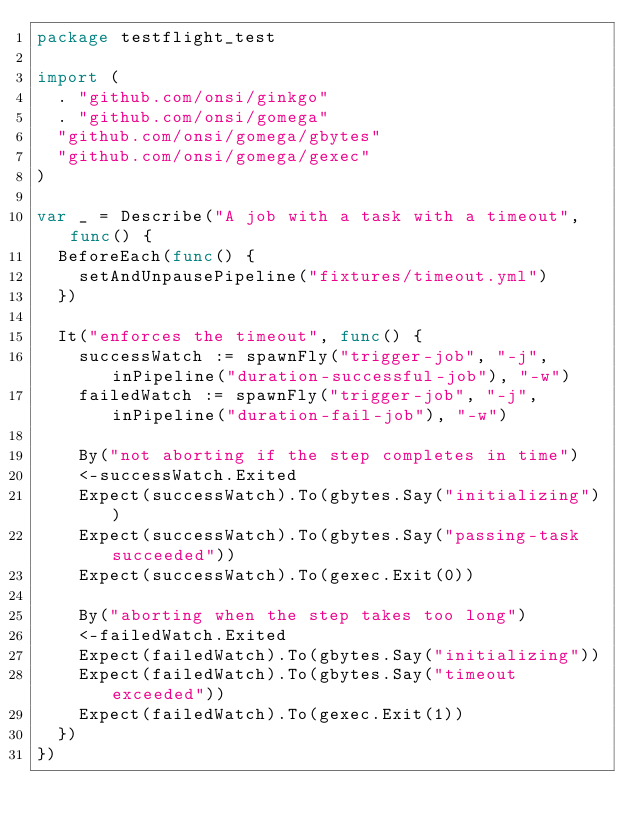<code> <loc_0><loc_0><loc_500><loc_500><_Go_>package testflight_test

import (
	. "github.com/onsi/ginkgo"
	. "github.com/onsi/gomega"
	"github.com/onsi/gomega/gbytes"
	"github.com/onsi/gomega/gexec"
)

var _ = Describe("A job with a task with a timeout", func() {
	BeforeEach(func() {
		setAndUnpausePipeline("fixtures/timeout.yml")
	})

	It("enforces the timeout", func() {
		successWatch := spawnFly("trigger-job", "-j", inPipeline("duration-successful-job"), "-w")
		failedWatch := spawnFly("trigger-job", "-j", inPipeline("duration-fail-job"), "-w")

		By("not aborting if the step completes in time")
		<-successWatch.Exited
		Expect(successWatch).To(gbytes.Say("initializing"))
		Expect(successWatch).To(gbytes.Say("passing-task succeeded"))
		Expect(successWatch).To(gexec.Exit(0))

		By("aborting when the step takes too long")
		<-failedWatch.Exited
		Expect(failedWatch).To(gbytes.Say("initializing"))
		Expect(failedWatch).To(gbytes.Say("timeout exceeded"))
		Expect(failedWatch).To(gexec.Exit(1))
	})
})
</code> 